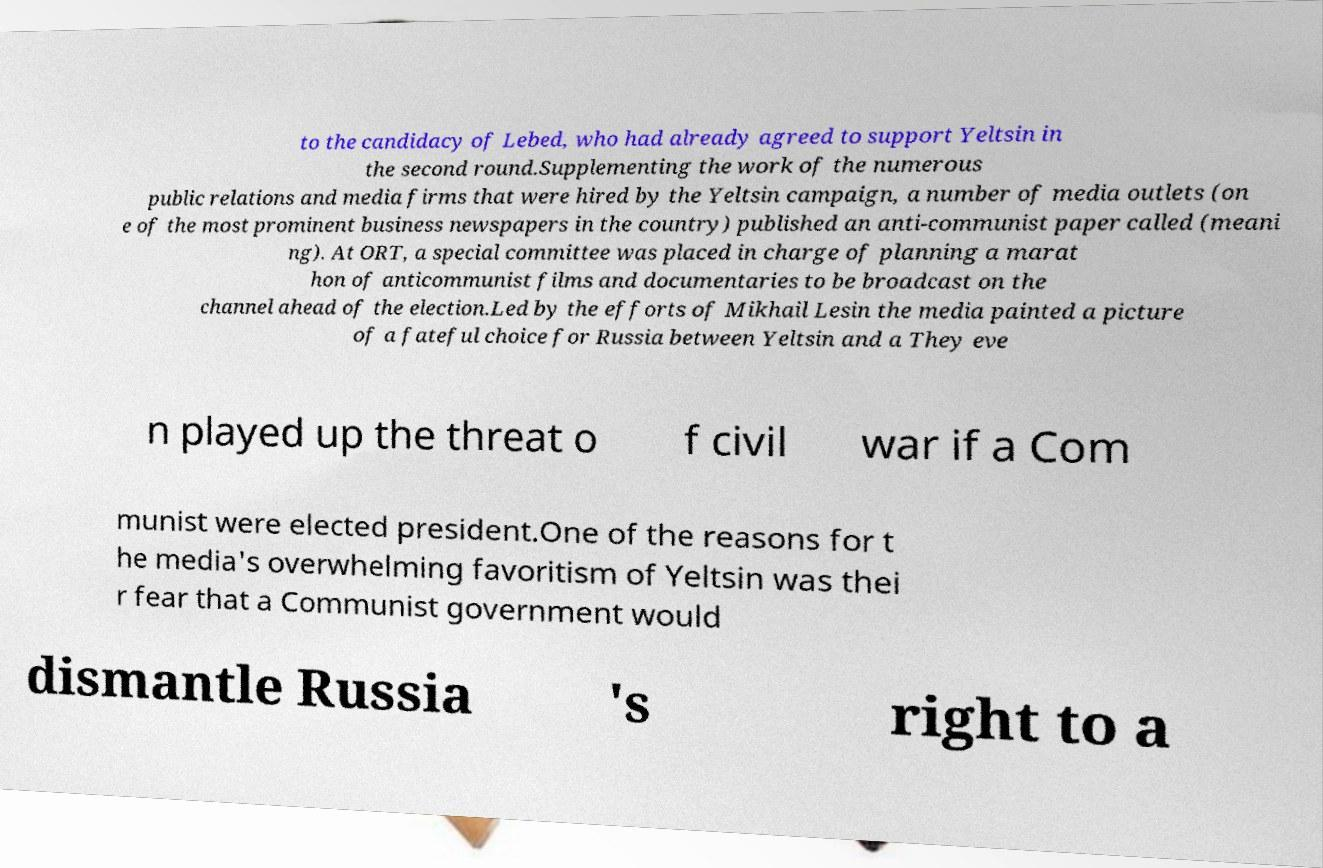For documentation purposes, I need the text within this image transcribed. Could you provide that? to the candidacy of Lebed, who had already agreed to support Yeltsin in the second round.Supplementing the work of the numerous public relations and media firms that were hired by the Yeltsin campaign, a number of media outlets (on e of the most prominent business newspapers in the country) published an anti-communist paper called (meani ng). At ORT, a special committee was placed in charge of planning a marat hon of anticommunist films and documentaries to be broadcast on the channel ahead of the election.Led by the efforts of Mikhail Lesin the media painted a picture of a fateful choice for Russia between Yeltsin and a They eve n played up the threat o f civil war if a Com munist were elected president.One of the reasons for t he media's overwhelming favoritism of Yeltsin was thei r fear that a Communist government would dismantle Russia 's right to a 